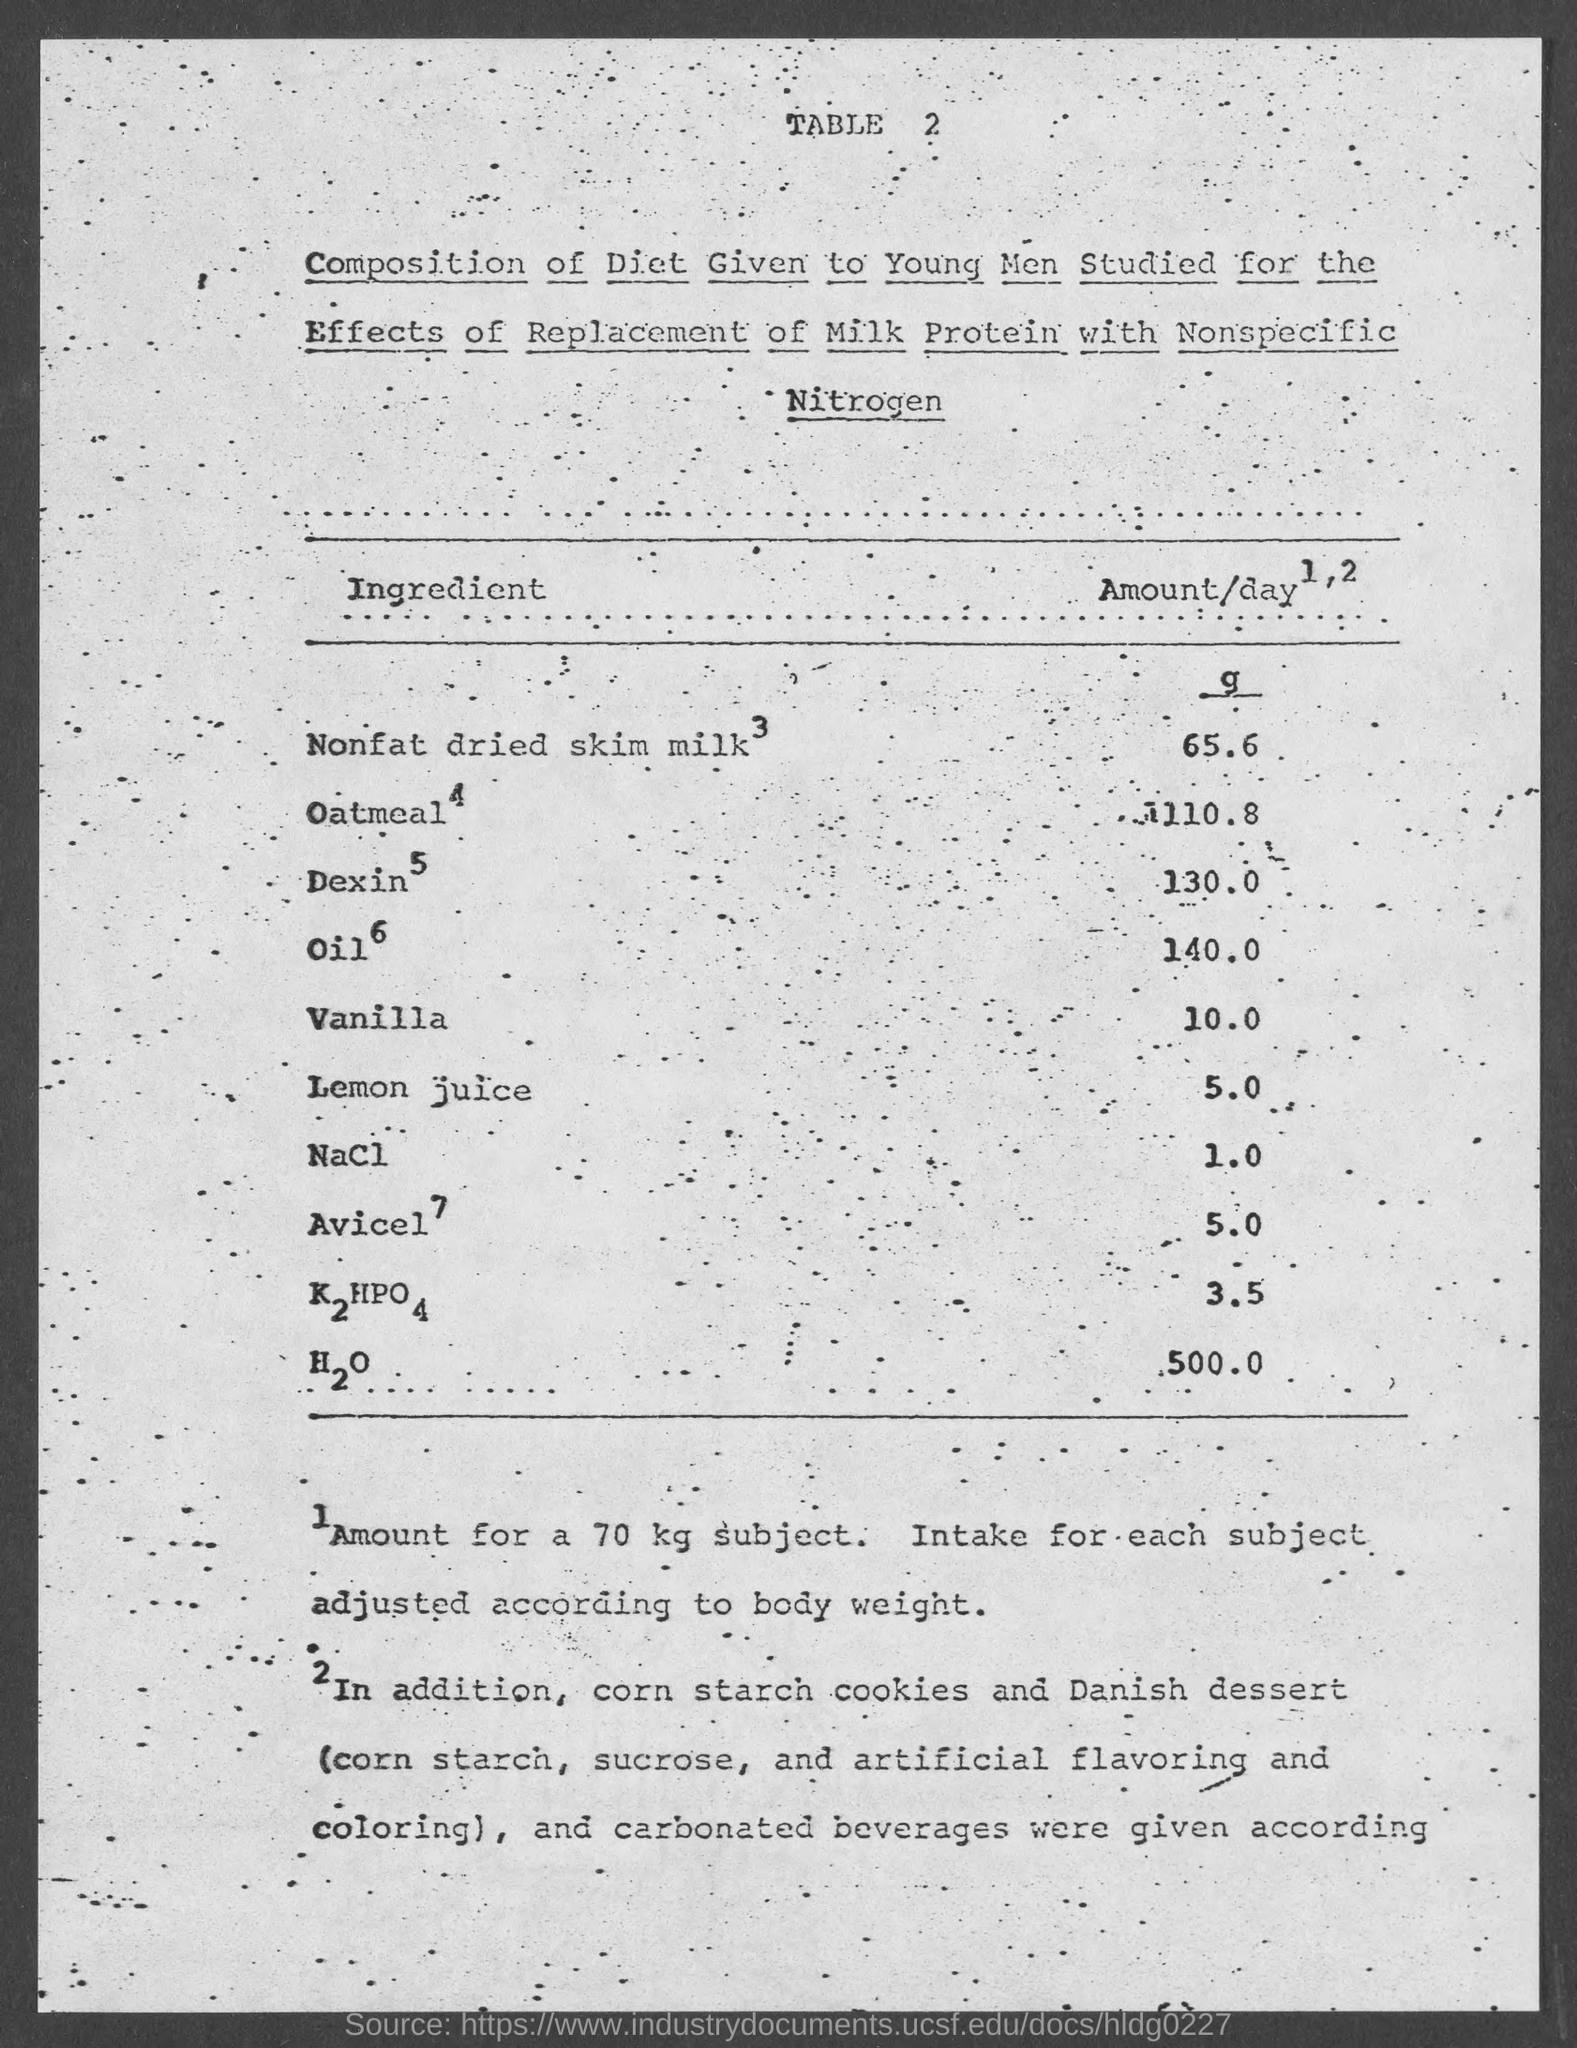What is the table number?
Make the answer very short. 2. What is the amount of H2O?
Your answer should be very brief. 500.0. What is the amount of Nacl?
Keep it short and to the point. 1.0. Which ingredient is present in a large amount?
Your answer should be very brief. H2O. Which ingredient is present in a small amount?
Offer a very short reply. NaCl. What is the title of the first column of the table?
Give a very brief answer. Ingredient. What is the amount of Lemon juice?
Make the answer very short. 5.0. What is the amount of Vanilla?
Your response must be concise. 10.0. 